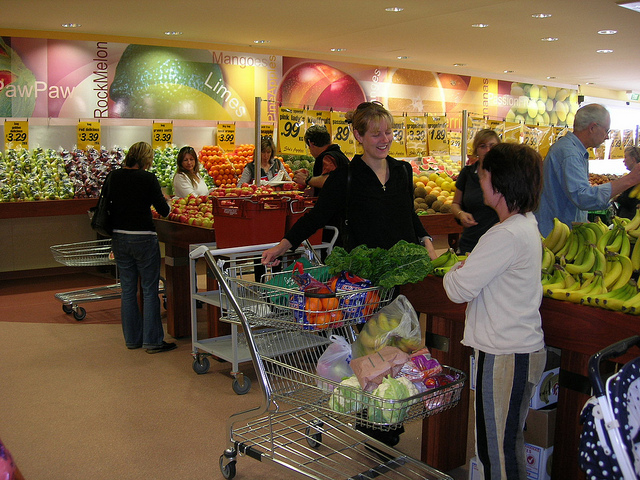Please identify all text content in this image. RockMelonb Mangoes Limes 89 .99 1 SBUBU 1.89 9 399 3.39 3.39 3.29 Paw aw 